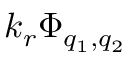Convert formula to latex. <formula><loc_0><loc_0><loc_500><loc_500>k _ { r } \Phi _ { q _ { 1 } , q _ { 2 } }</formula> 